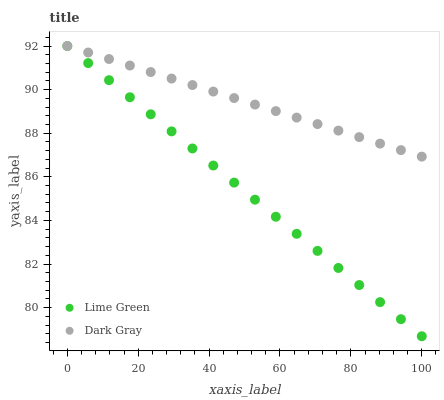Does Lime Green have the minimum area under the curve?
Answer yes or no. Yes. Does Dark Gray have the maximum area under the curve?
Answer yes or no. Yes. Does Lime Green have the maximum area under the curve?
Answer yes or no. No. Is Dark Gray the smoothest?
Answer yes or no. Yes. Is Lime Green the roughest?
Answer yes or no. Yes. Is Lime Green the smoothest?
Answer yes or no. No. Does Lime Green have the lowest value?
Answer yes or no. Yes. Does Lime Green have the highest value?
Answer yes or no. Yes. Does Dark Gray intersect Lime Green?
Answer yes or no. Yes. Is Dark Gray less than Lime Green?
Answer yes or no. No. Is Dark Gray greater than Lime Green?
Answer yes or no. No. 